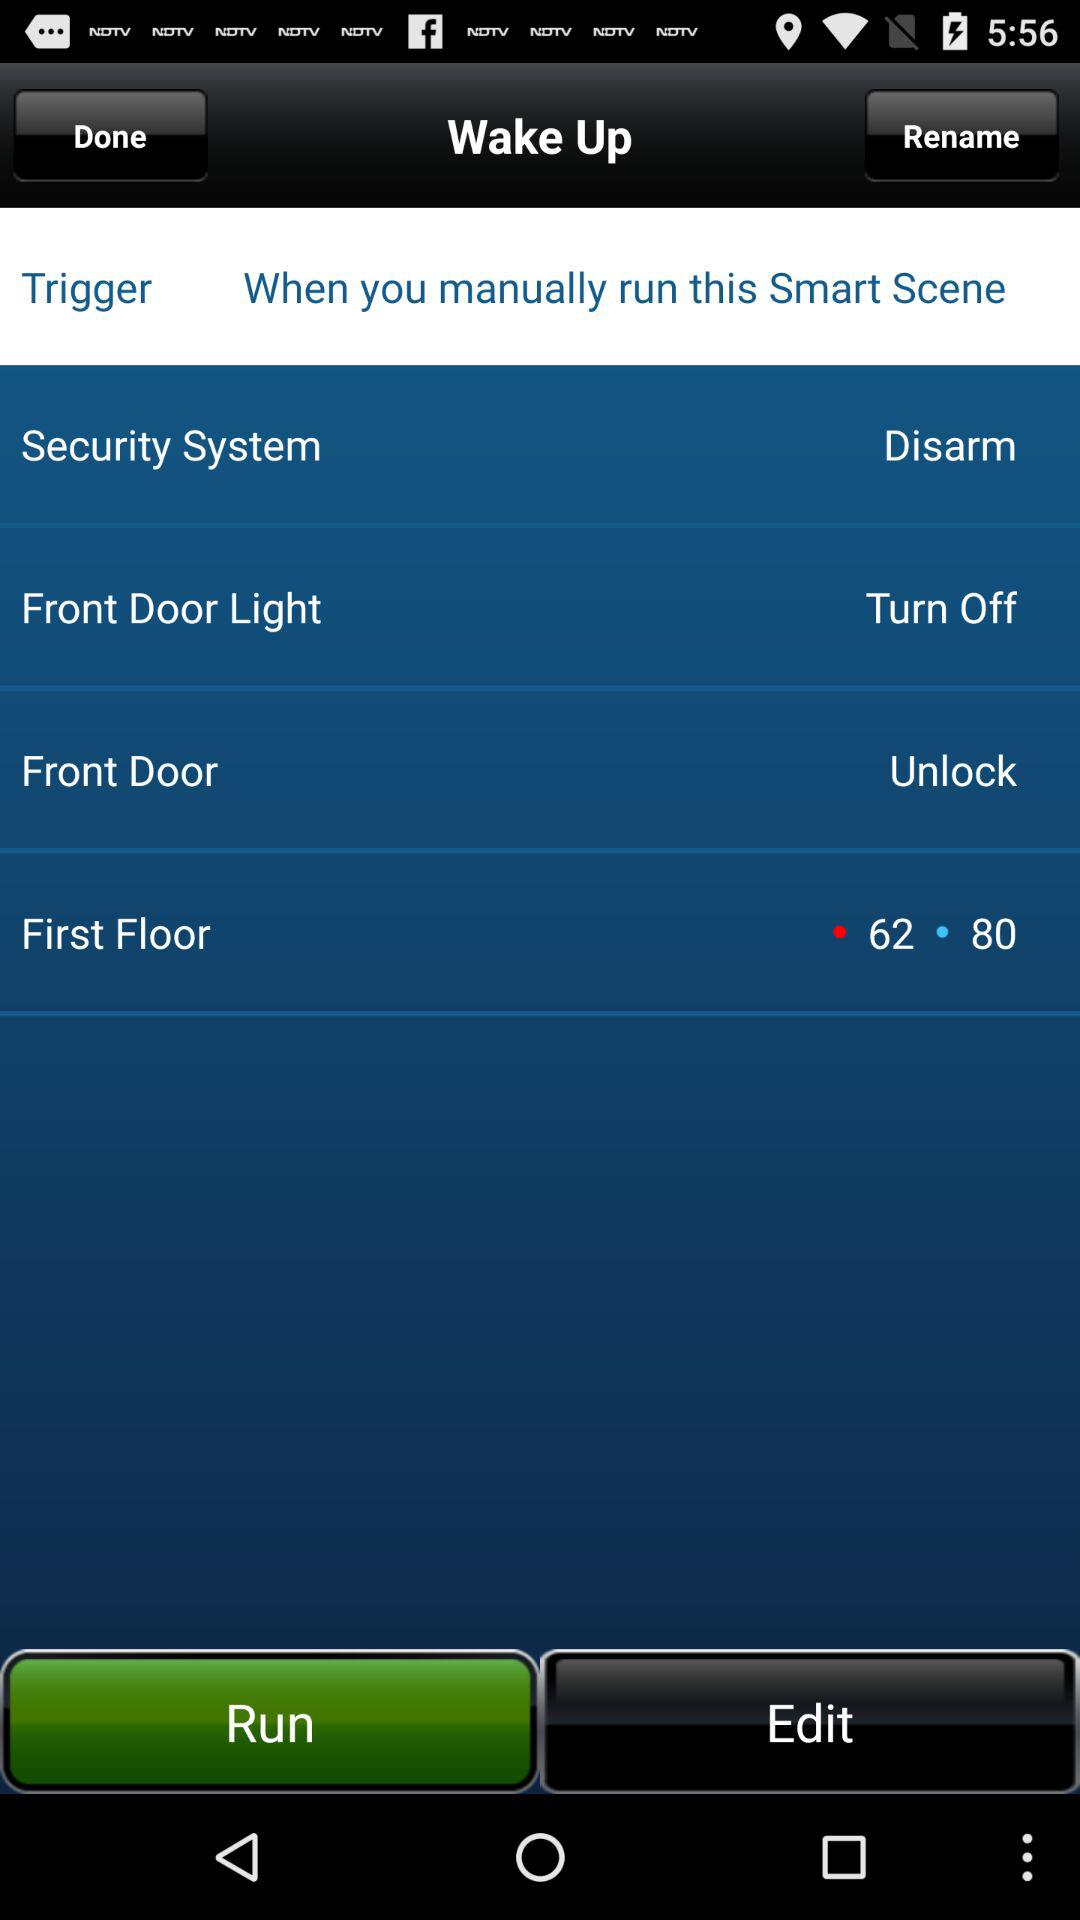What is the status of the "Security System"? The status of the "Security System" is "Disarm". 